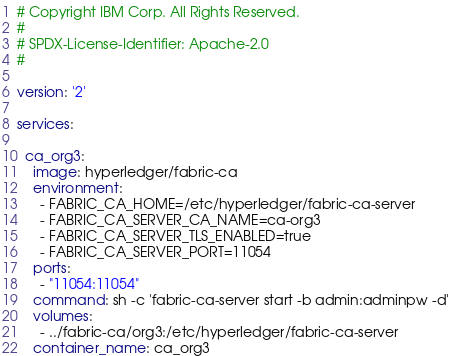<code> <loc_0><loc_0><loc_500><loc_500><_YAML_># Copyright IBM Corp. All Rights Reserved.
#
# SPDX-License-Identifier: Apache-2.0
#

version: '2'

services:

  ca_org3:
    image: hyperledger/fabric-ca
    environment:
      - FABRIC_CA_HOME=/etc/hyperledger/fabric-ca-server
      - FABRIC_CA_SERVER_CA_NAME=ca-org3
      - FABRIC_CA_SERVER_TLS_ENABLED=true
      - FABRIC_CA_SERVER_PORT=11054
    ports:
      - "11054:11054"
    command: sh -c 'fabric-ca-server start -b admin:adminpw -d'
    volumes:
      - ../fabric-ca/org3:/etc/hyperledger/fabric-ca-server
    container_name: ca_org3
</code> 